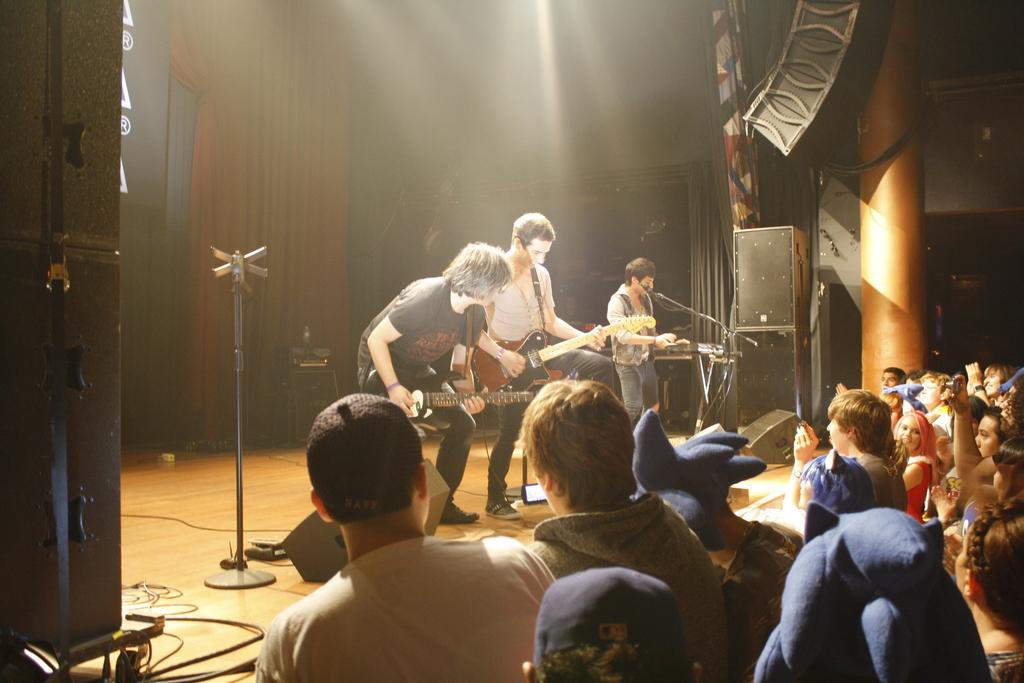What are the people on stage doing? The people on stage are playing guitar. Who is observing the performance? There are people watching the play. Are there any devices being used to record the performance? Some people are capturing videos of the play. Can you describe any equipment used for sound amplification? There is a sound box placed at the corner. What type of fire can be seen on the stage during the performance? There is no fire present on the stage during the performance; the people on stage are playing guitar. What medical operation is being performed on the stage? There is no medical operation being performed on the stage; the people on stage are playing guitar. 